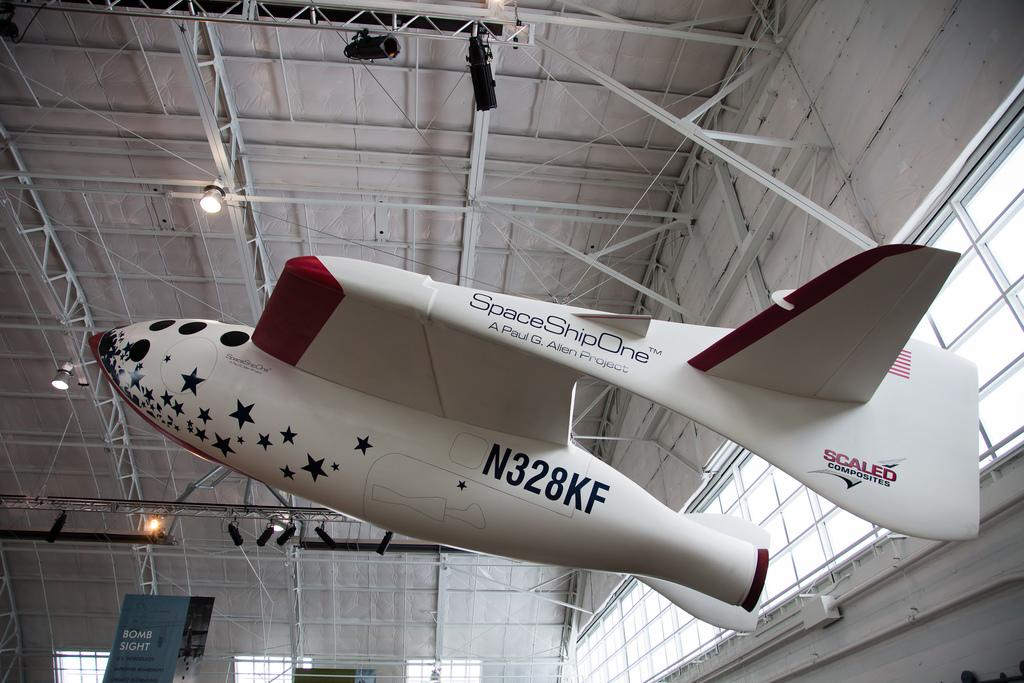<image>
Present a compact description of the photo's key features. A plane is hanging with the logo Scaled Composites on the tail. 